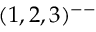Convert formula to latex. <formula><loc_0><loc_0><loc_500><loc_500>( 1 , 2 , 3 ) ^ { - - }</formula> 